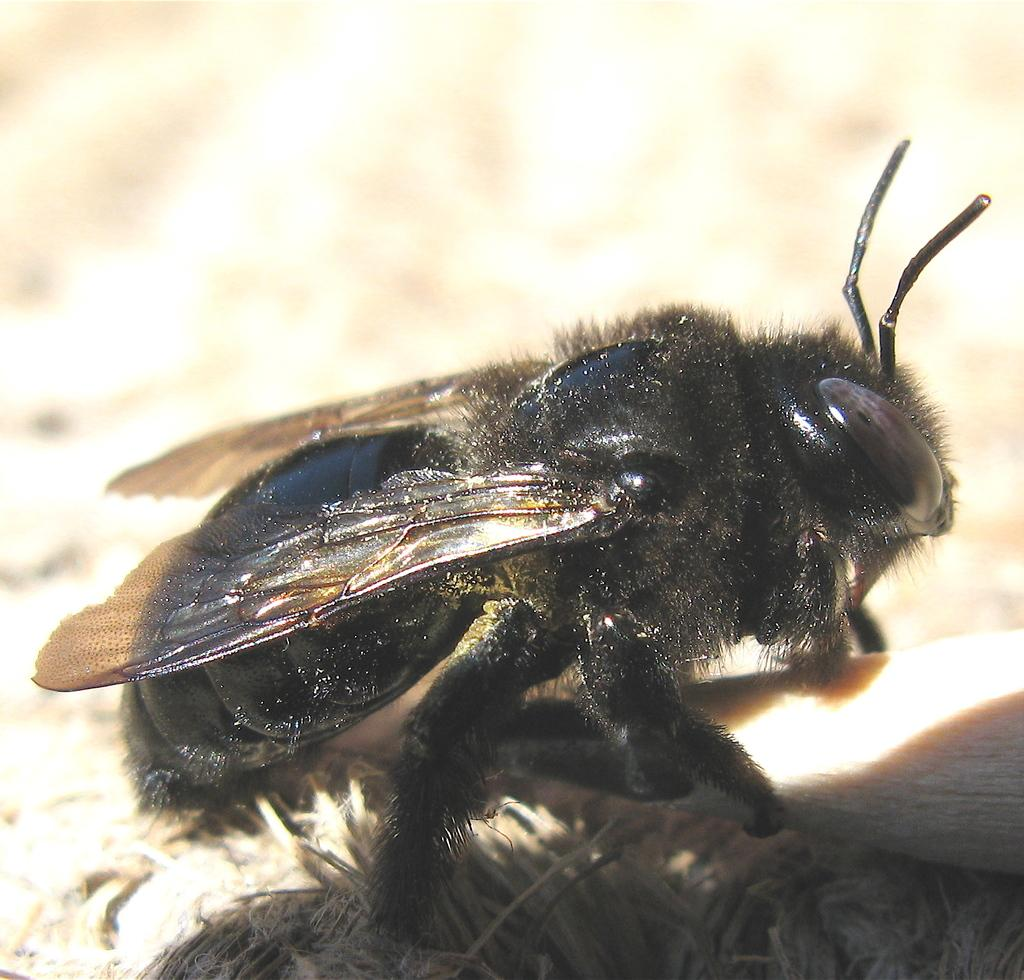What type of creature is in the image? There is a black insect in the image. What feature does the insect have? The insect has wings. Can you describe the background of the image? The background of the image is blurred. What type of prose can be seen on the side of the insect in the image? There is no prose visible on the insect or anywhere else in the image. 